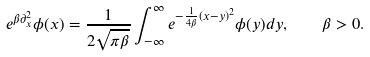Convert formula to latex. <formula><loc_0><loc_0><loc_500><loc_500>e ^ { \beta \partial _ { x } ^ { 2 } } \phi ( x ) = \frac { 1 } { 2 \sqrt { \pi \beta } } \int _ { - \infty } ^ { \infty } e ^ { - \frac { 1 } { 4 \beta } ( x - y ) ^ { 2 } } \phi ( y ) d y , \quad \beta > 0 .</formula> 